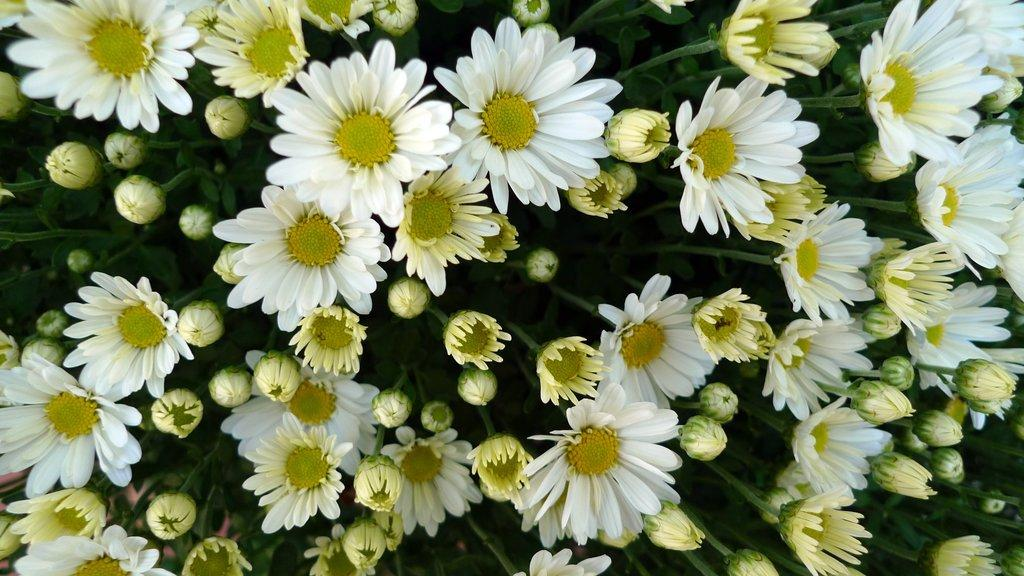What type of plants can be seen in the image? There are flowers in the image. What stage of growth are the plants in the image? There are buds on plants in the image. What type of pets can be seen in the image? There are no pets visible in the image; it features flowers and plants. Is there a store selling flowers in the image? There is no store present in the image; it shows flowers and plants in a natural setting. 